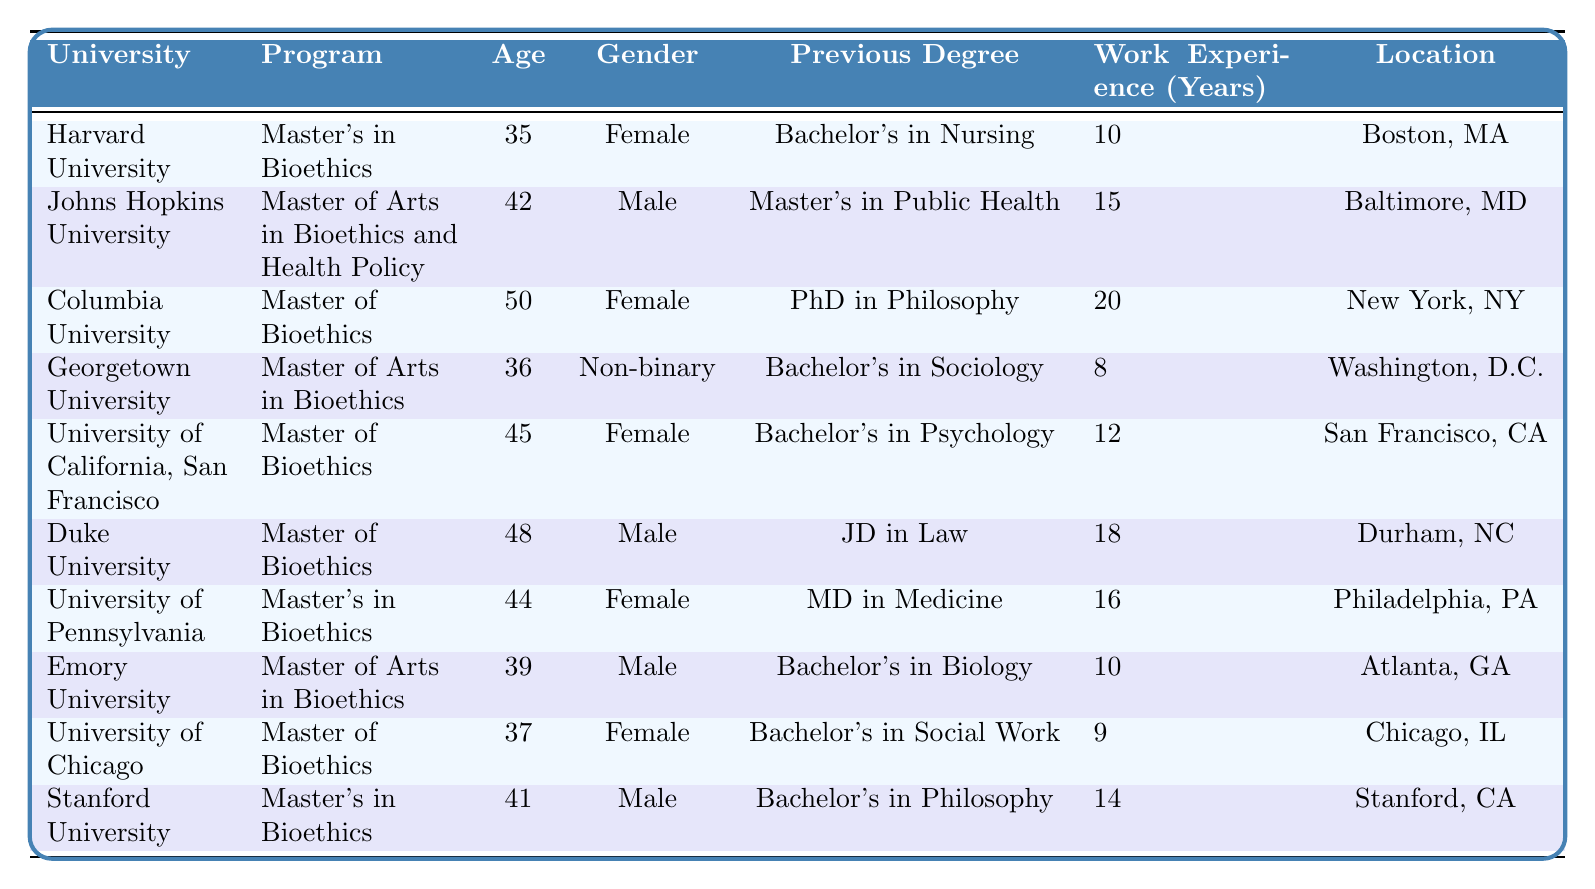What is the age of the student from Harvard University? The table lists Harvard University with an age of 35 for the student enrolled in the Master's in Bioethics program.
Answer: 35 How many years of work experience does the student from Duke University have? The student at Duke University has 18 years of work experience as noted in the table under the corresponding entry.
Answer: 18 Which university has a Non-binary student enrolled in a Bioethics program? Georgetown University lists a Non-binary student enrolled in the Master's in Bioethics program, as indicated in the gender column.
Answer: Georgetown University What is the previous degree of the student from the University of California, San Francisco? The table shows that the previous degree for the student at the University of California, San Francisco is a Bachelor's in Psychology.
Answer: Bachelor's in Psychology How many students in the table have a Master's degree as a previous degree? Reviewing the data, three students have a Master's degree as their previous degree: one from Johns Hopkins University, one from University of Pennsylvania, and one from Duke University. The total count is 3.
Answer: 3 What is the average age of students in Bioethics programs from this table? To find the average age, sum all the ages: 35 + 42 + 50 + 36 + 45 + 48 + 44 + 39 + 37 + 41 = 417. Divide by the number of students (10): 417 / 10 = 41.7.
Answer: 41.7 Is there a student from Emory University with more than 10 years of work experience? The table shows that the student from Emory University has 10 years of work experience, which is not more than 10. Therefore, the answer is false.
Answer: No Which student's previous degree is a PhD in Philosophy? According to the table, the student from Columbia University has a PhD in Philosophy listed as their previous degree.
Answer: Columbia University What is the median age of students in the table? To find the median, list the ages in ascending order: 35, 36, 37, 39, 41, 42, 44, 45, 48, 50. The median is the average of the 5th and 6th ages: (41 + 42) / 2 = 41.5.
Answer: 41.5 Are there more male students than female students in the table? The count of male students is 5 (Johns Hopkins, Duke, Emory, Stanford) and female students is 4 (Harvard, Columbia, UCSF, University of Chicago). Since 5 is greater than 4, the answer is yes.
Answer: Yes 